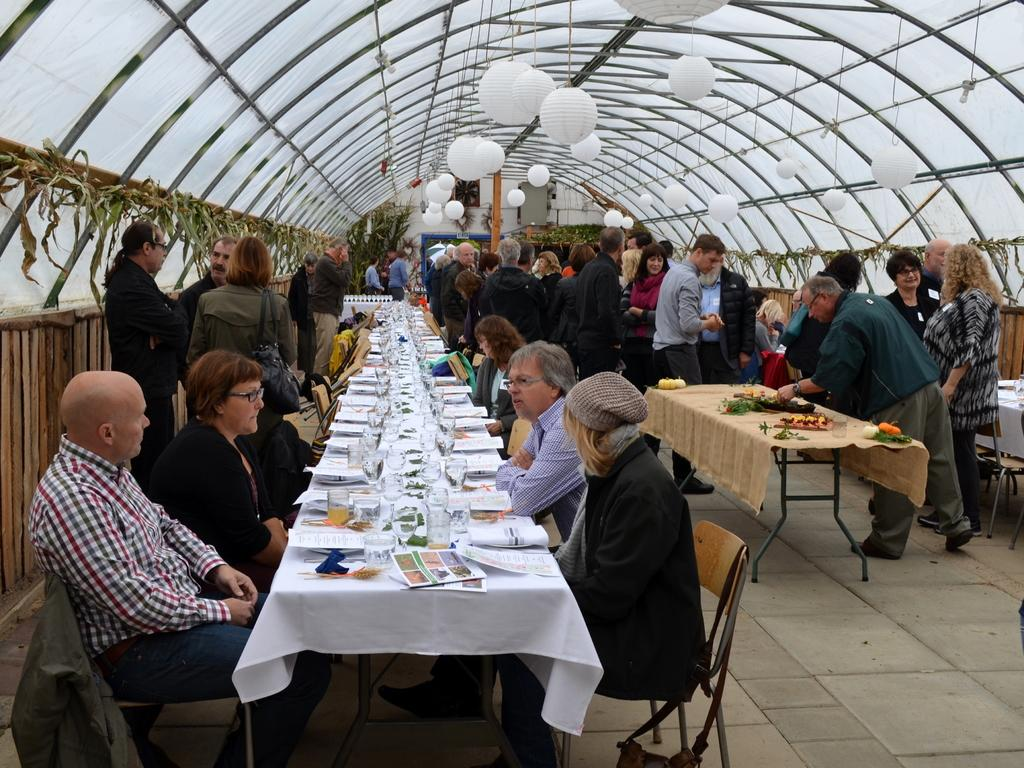How many people are in the image? There is a group of people in the image. What are some of the people doing in the image? Some people are sitting on chairs, while others are standing on the floor. What is present in the image besides the people? There is a table in the image. What can be found on the table? There are objects on the table. What type of pleasure can be seen on the faces of the people in the image? There is no indication of pleasure or any specific emotions on the faces of the people in the image. 